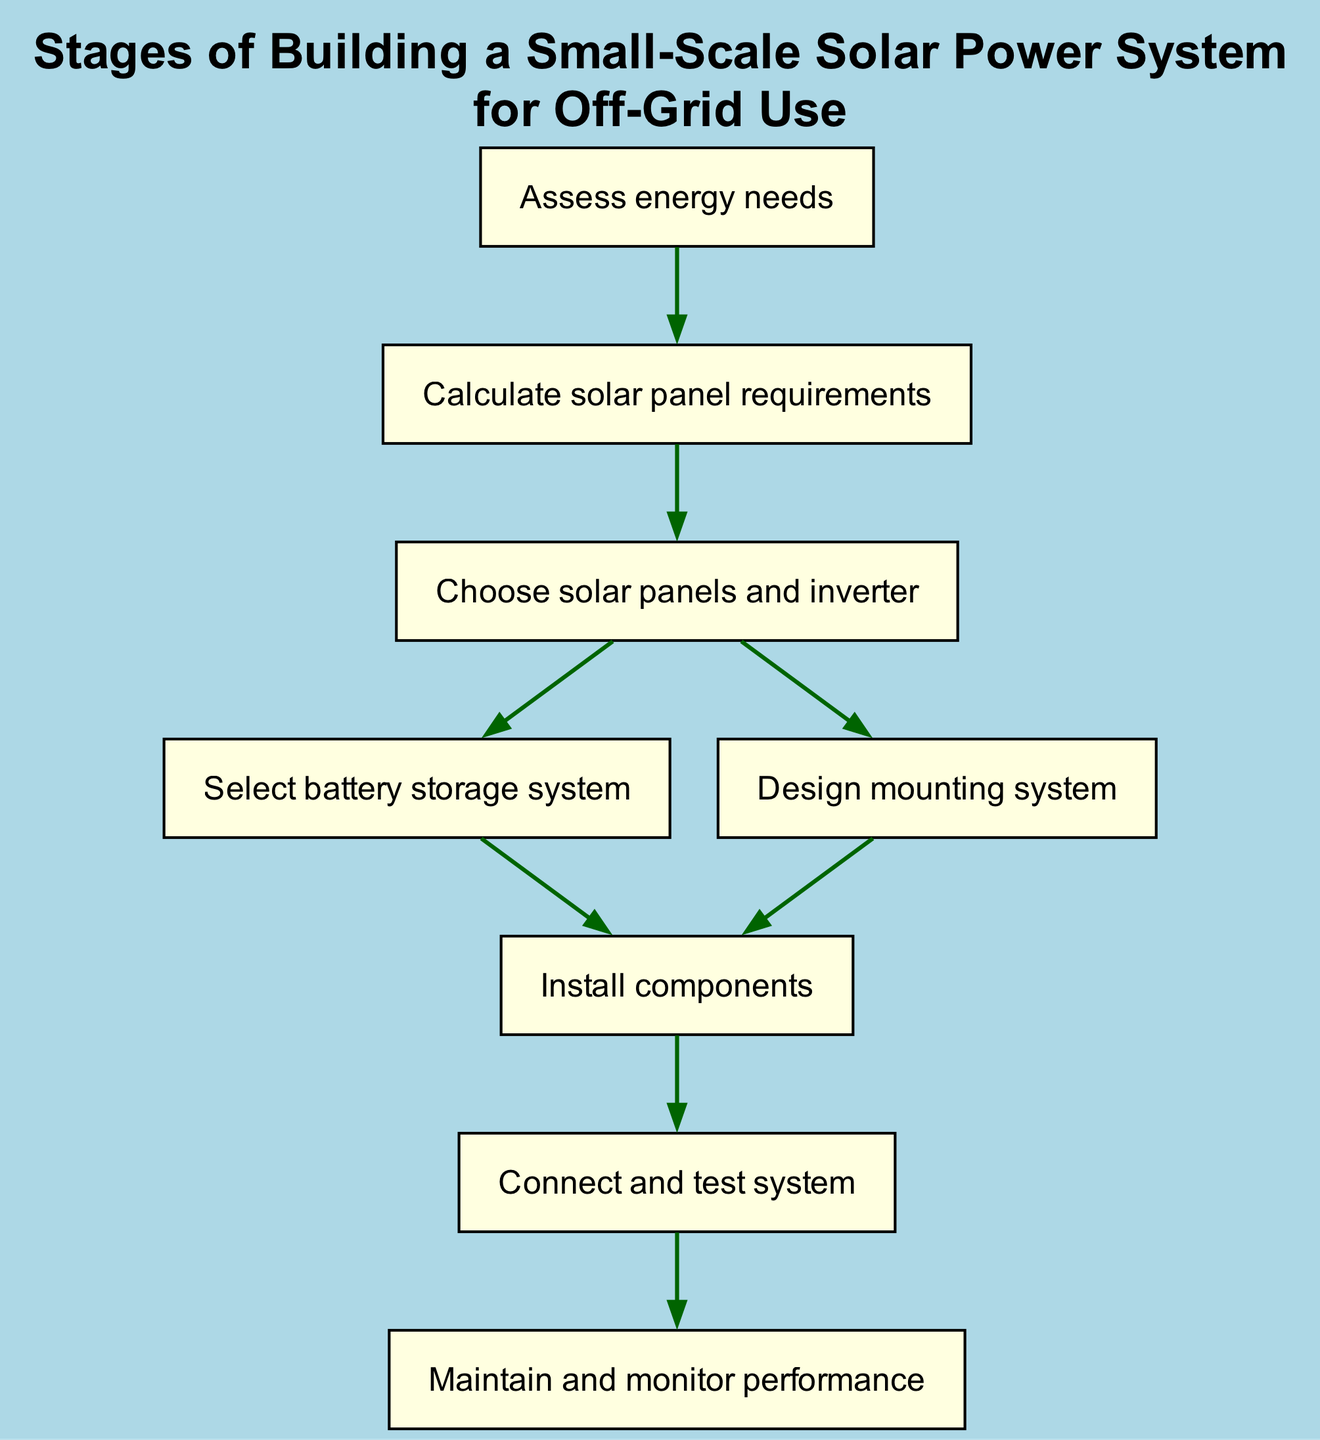What is the first step in the solar power system building process? The first step, as indicated in the diagram, is to "Assess energy needs." This step is positioned at the top of the flow chart, showing it is the starting point of the instruction sequence.
Answer: Assess energy needs How many total steps are involved in the process? To determine the total steps, we can count the nodes in the diagram. There are 8 nodes representing individual steps, indicating that there are 8 total steps involved in building the solar power system.
Answer: 8 Which step follows "Choose solar panels and inverter"? The diagram shows that the step following "Choose solar panels and inverter" leads to two paths: "Select battery storage system" and "Design mounting system." However, since both are next steps, we can conclude that the next step would be to either select a battery storage system or design the mounting system.
Answer: Select battery storage system or Design mounting system What is the last step in the flow chart? Observing the diagram, the last step in the process is "Maintain and monitor performance," as it is the final node without any subsequent steps leading away from it.
Answer: Maintain and monitor performance If you skip selecting the battery storage system, what is the next step? According to the flow chart, both "Select battery storage system" and "Design mounting system" lead to the same next step, which is "Install components." Therefore, if the battery storage system is skipped, the next step would still be to "Install components."
Answer: Install components What is the relationship between "Install components" and "Connect and test system"? The relationship is sequential; "Install components" leads directly to "Connect and test system," indicating that after installing the components, the next logical step is to connect and test the entire solar power system.
Answer: Connect and test system How many steps are there before connecting and testing the system? To find out how many steps precede "Connect and test system," we need to count from the beginning of the flowchart until that point. The steps before "Connect and test system" are: "Assess energy needs," "Calculate solar panel requirements," "Choose solar panels and inverter," and "Install components." This makes a total of 5 steps before moving to connecting and testing.
Answer: 5 What step comes right after "Connect and test system"? The flow chart indicates that the step directly following "Connect and test system" is "Maintain and monitor performance," highlighting that once the system is tested, the maintenance phase begins.
Answer: Maintain and monitor performance 